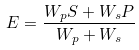<formula> <loc_0><loc_0><loc_500><loc_500>E = \frac { W _ { p } S + W _ { s } P } { W _ { p } + W _ { s } }</formula> 